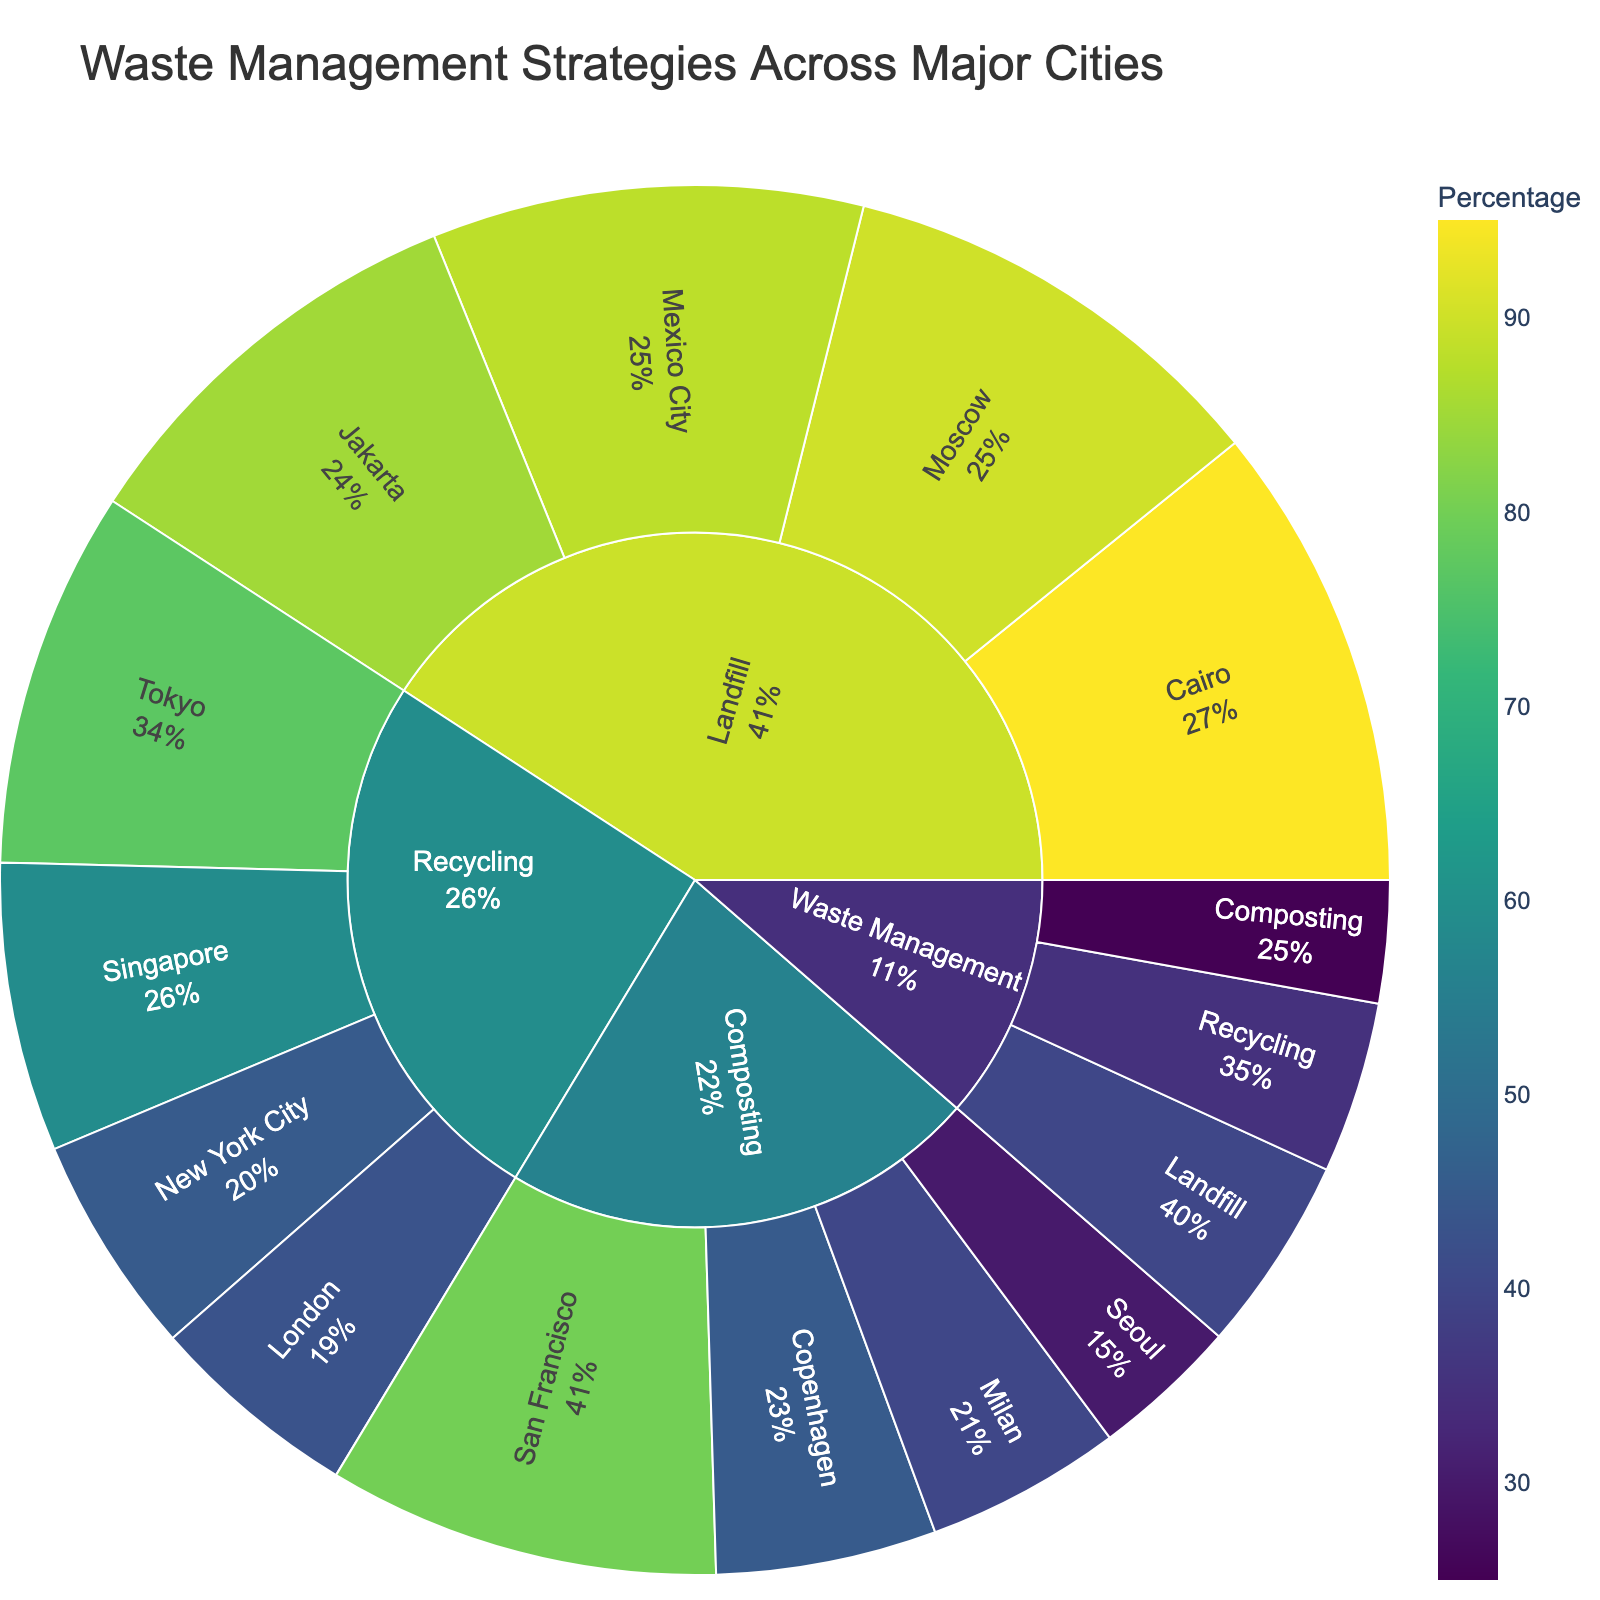What is the title of the sunburst plot? Look at the top of the plot. The title is clearly displayed there.
Answer: Waste Management Strategies Across Major Cities What percentage of waste is managed through composting? Refer to the 'Composting' section of the sunburst plot; the percentage should be displayed.
Answer: 25% Which city has the highest percentage of waste managed through landfill? Examine the 'Landfill' subsection and compare the percentages for each city.
Answer: Cairo How much higher is the recycling percentage in Tokyo compared to London? Find the recycling percentages for Tokyo and London and calculate their difference: Tokyo (77%) - London (43%).
Answer: 34% What is the combined percentage of recycling and composting for waste management? Add the percentages of recycling and composting: 35% (Recycling) + 25% (Composting).
Answer: 60% Which waste management strategy has the largest percentage? Look at the three main categories (Recycling, Composting, Landfill) and compare their percentages.
Answer: Landfill What is the average percentage of waste managed through recycling across the listed cities? Find the percentages for New York City (45%), Tokyo (77%), London (43%), and Singapore (59%). Calculate the average: (45 + 77 + 43 + 59) / 4.
Answer: 56% Which city has the lowest percentage of waste managed through composting? In the 'Composting' subsection, find the city with the smallest percentage.
Answer: Seoul Is the percentage of waste managed through landfill in Cairo higher than in Mexico City? Compare the percentages of landfill for Cairo (95%) and Mexico City (88%).
Answer: Yes What is the combined percentage of waste managed through landfill for Jakarta and Moscow? Add the landfill percentages for Jakarta (85%) and Moscow (90%).
Answer: 175% 